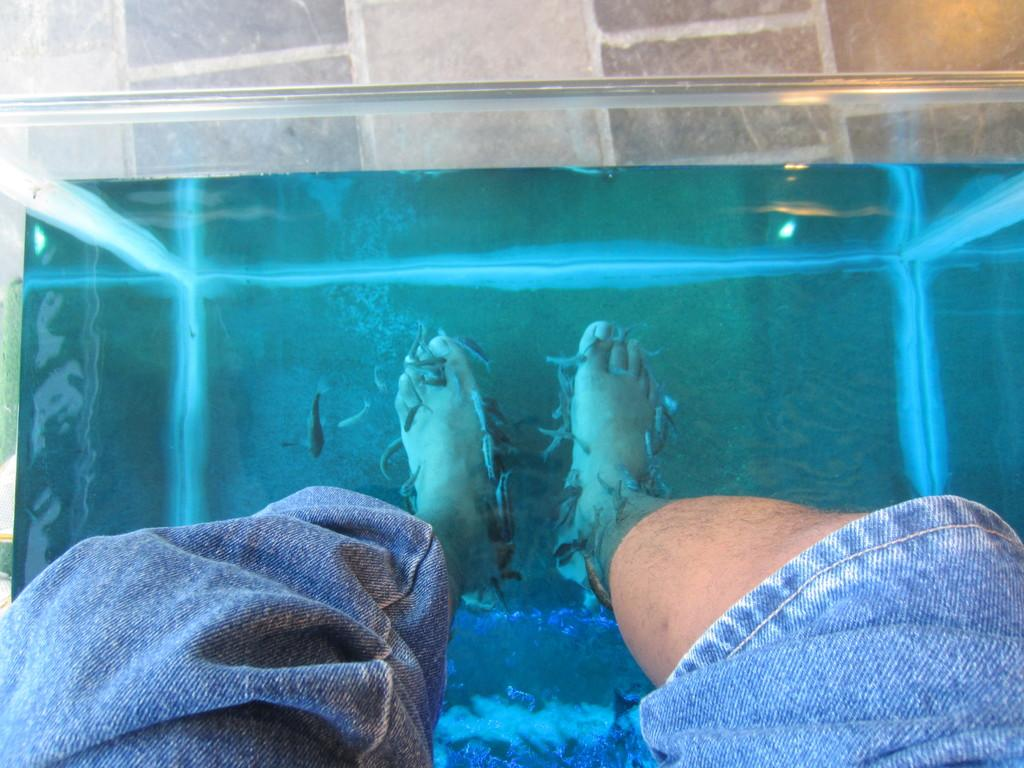Who or what is present in the image? There is a person in the image. What part of the person's body is in the water? The person's legs are in the water. What else can be seen in the image besides the person? There are fish in the image. What mountain range is visible in the background of the image? There is no mountain range visible in the image; it features a person with their legs in the water and fish. 